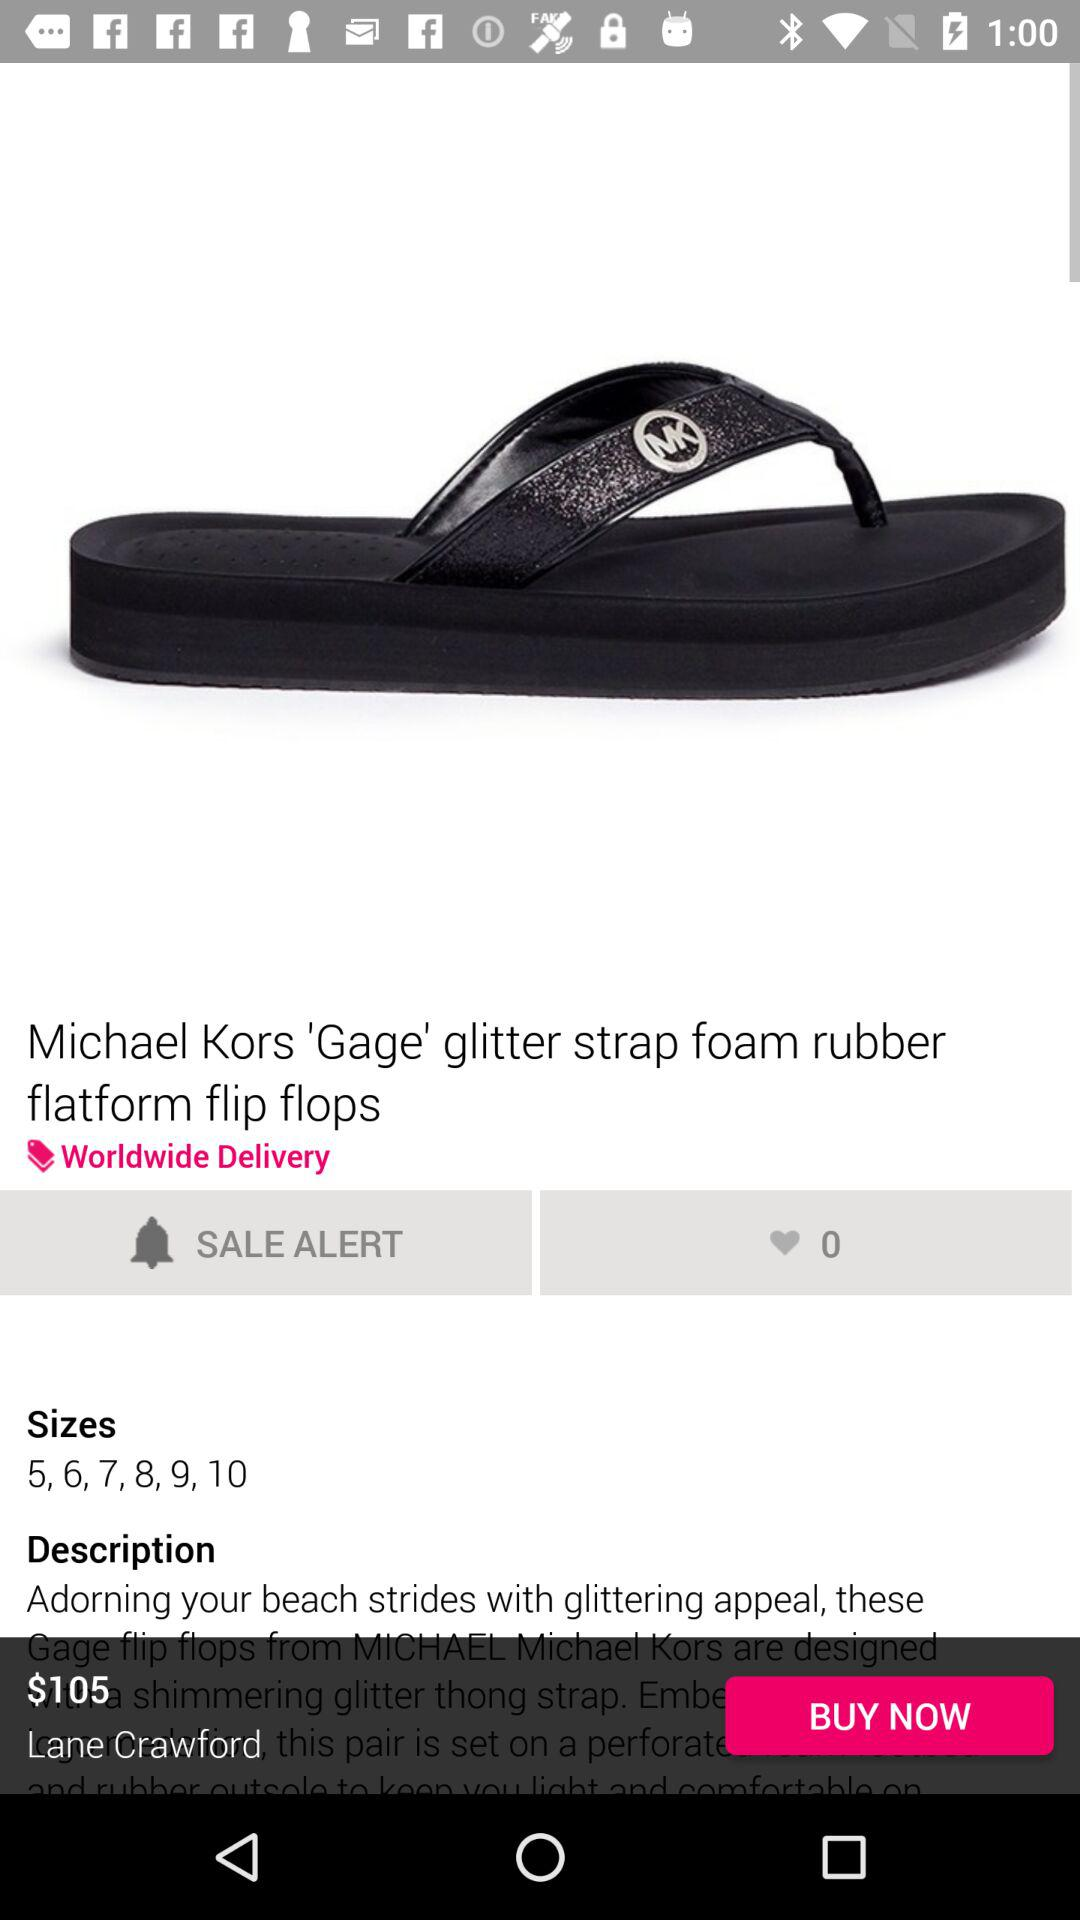What is the price of the item?
Answer the question using a single word or phrase. $105 